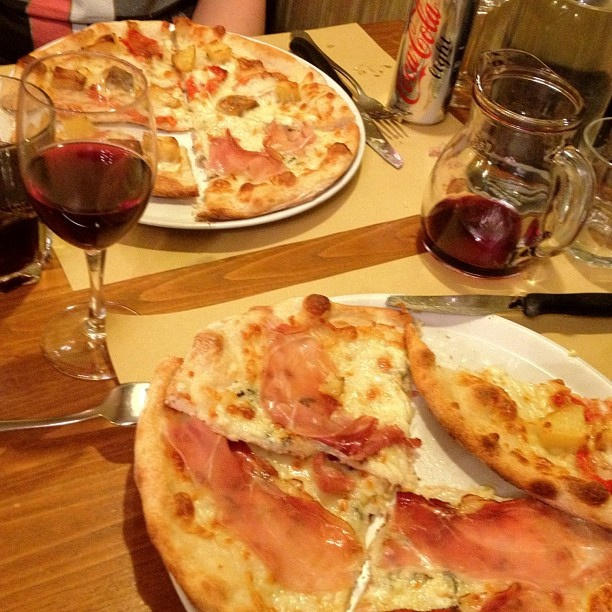Describe the objects in this image and their specific colors. I can see pizza in black, orange, and red tones, dining table in black, red, orange, and maroon tones, pizza in black, orange, red, and tan tones, cup in black, maroon, and olive tones, and wine glass in black, red, maroon, and orange tones in this image. 